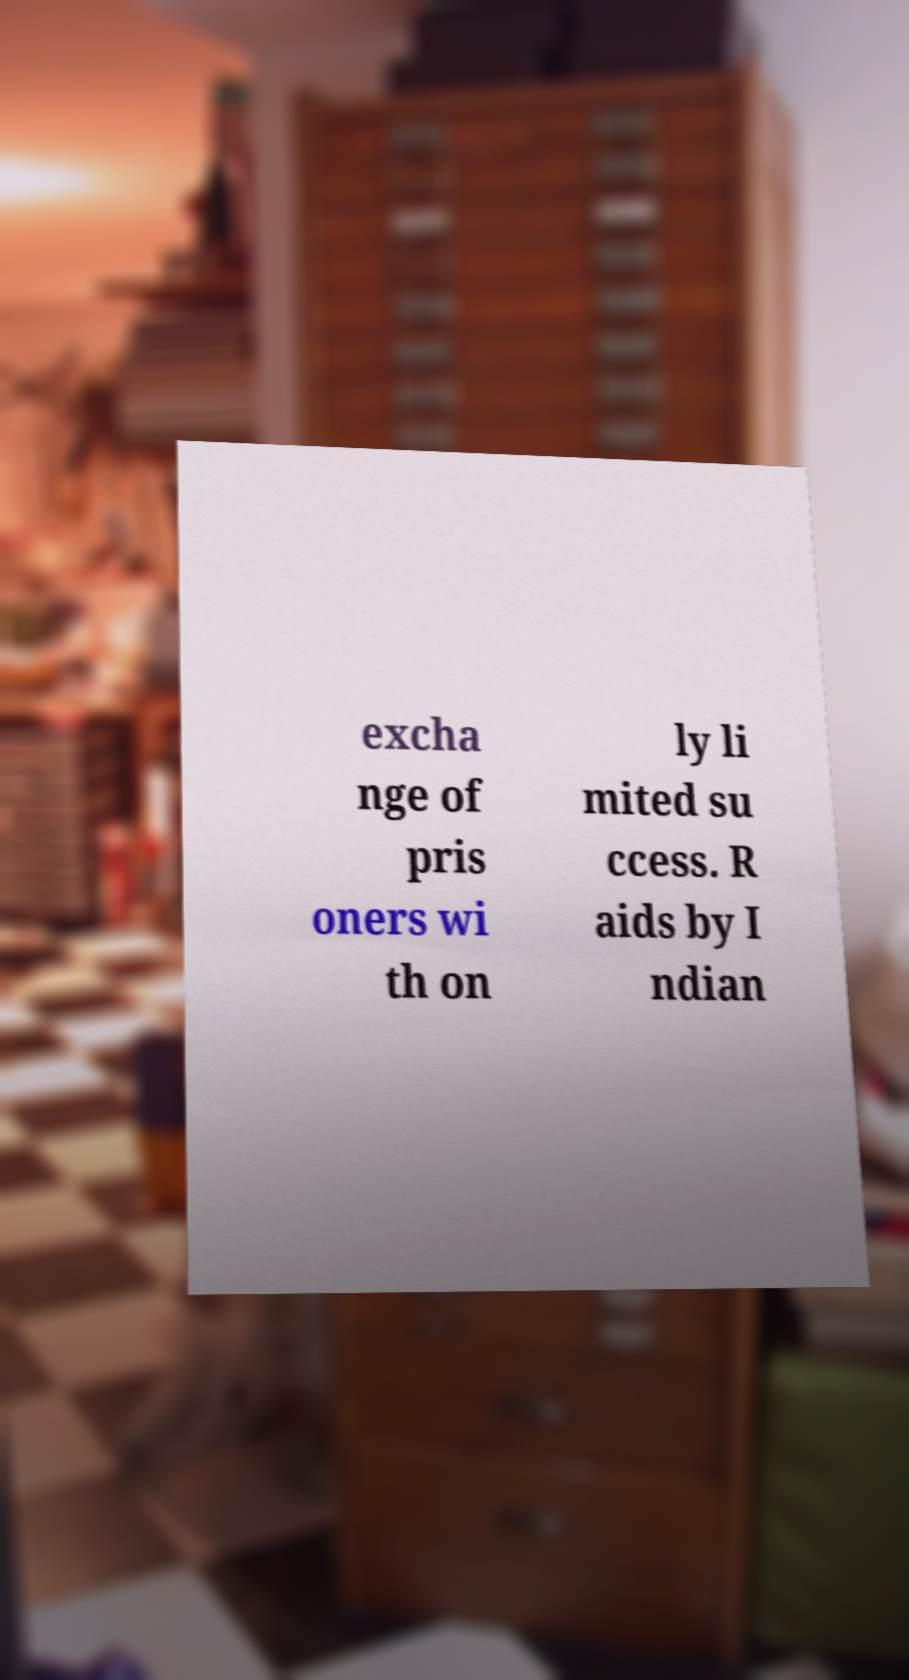Can you read and provide the text displayed in the image?This photo seems to have some interesting text. Can you extract and type it out for me? excha nge of pris oners wi th on ly li mited su ccess. R aids by I ndian 